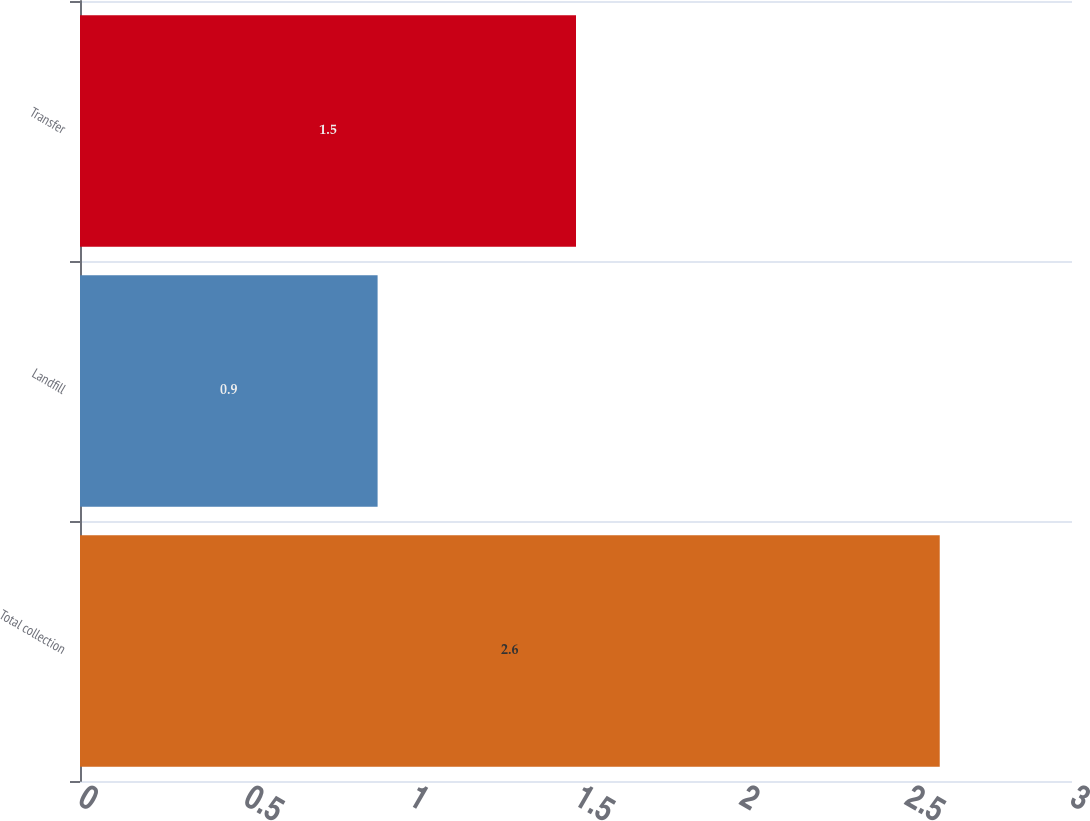Convert chart to OTSL. <chart><loc_0><loc_0><loc_500><loc_500><bar_chart><fcel>Total collection<fcel>Landfill<fcel>Transfer<nl><fcel>2.6<fcel>0.9<fcel>1.5<nl></chart> 